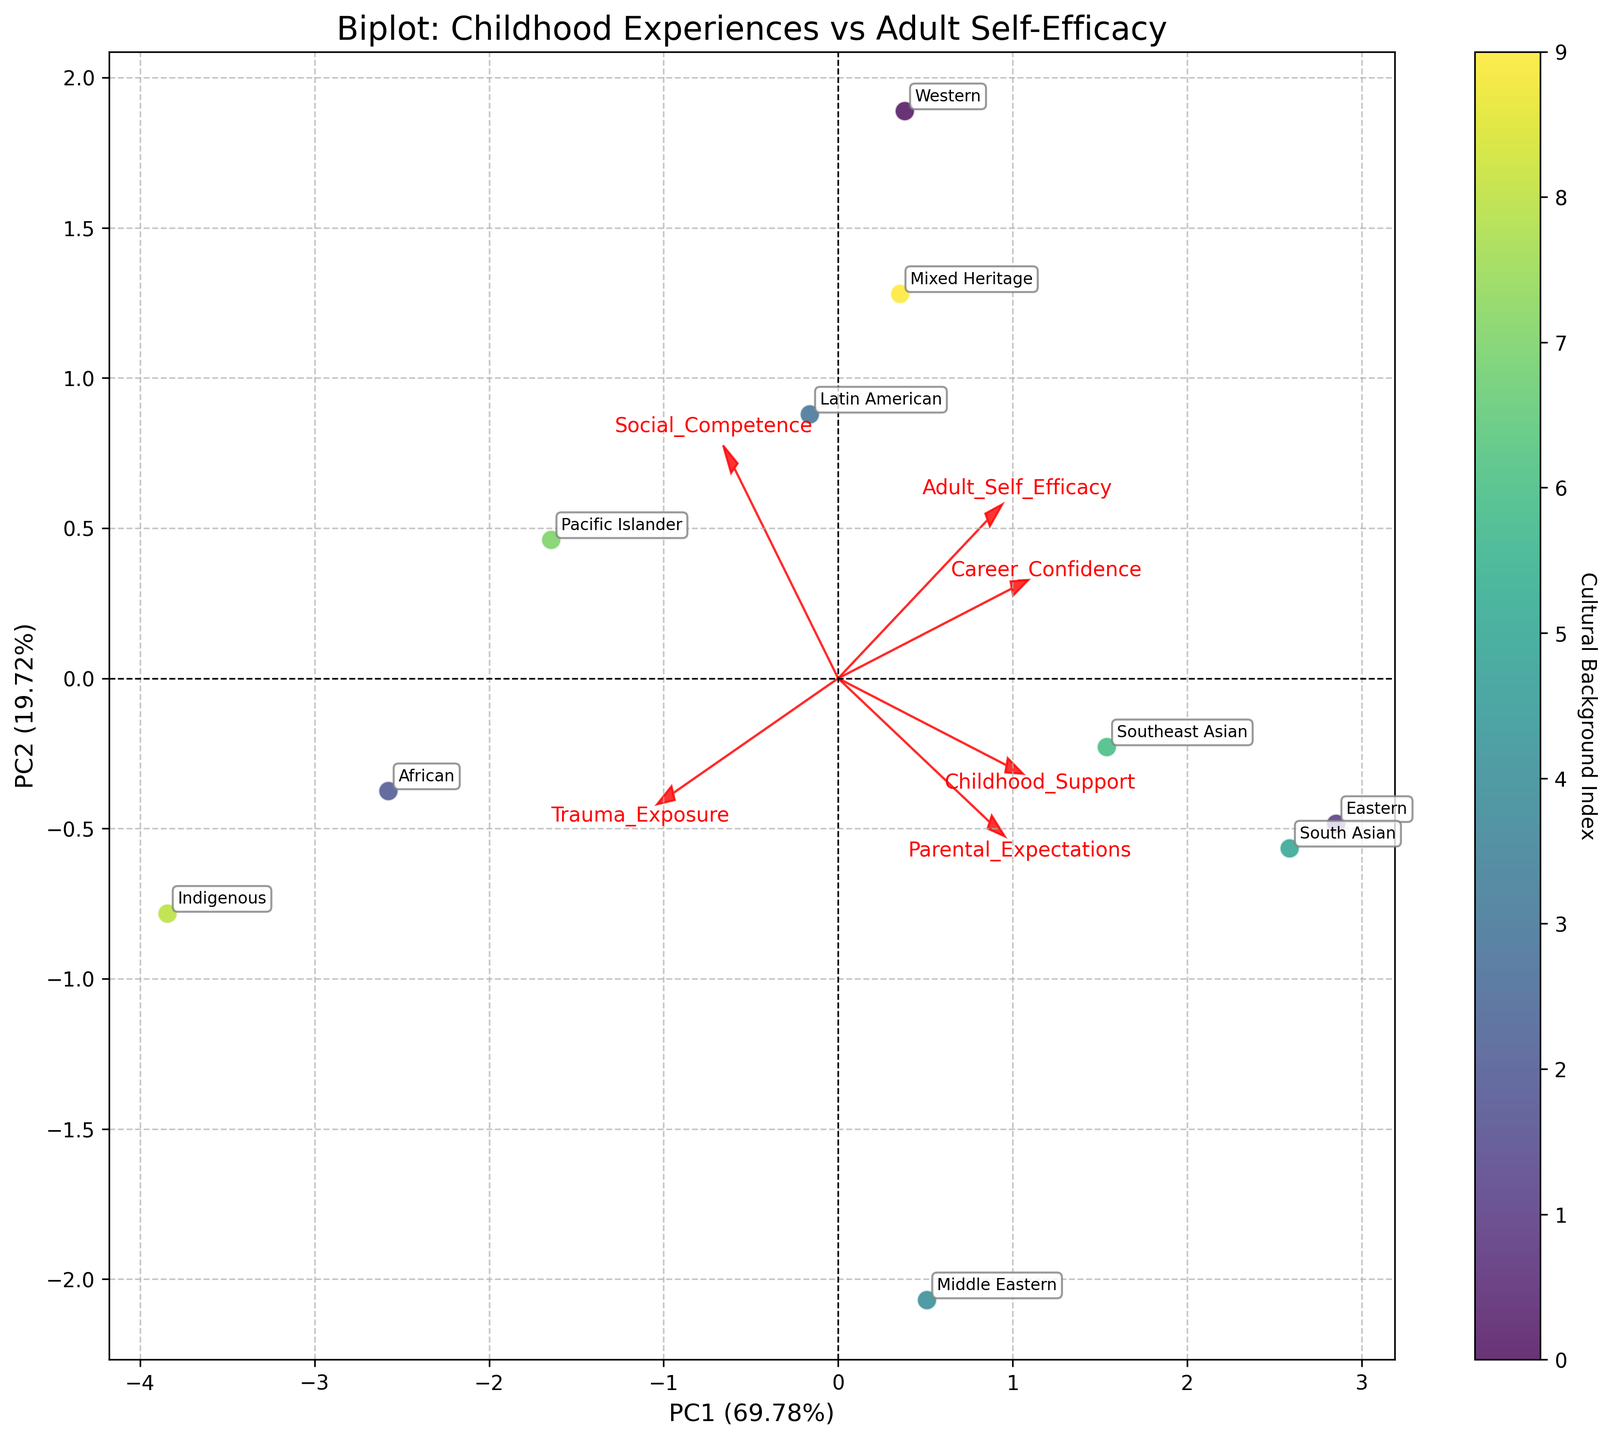What's the title of the biplot? The title can usually be found at the top center part of the plot. Here, it's written to explain what the biplot is about.
Answer: Biplot: Childhood Experiences vs Adult Self-Efficacy How many cultural backgrounds are represented in the biplot? By looking at the labels of the points, each data point is associated with a different cultural background. Counting these labels will give the number of different cultural backgrounds.
Answer: 10 Which variable appears to have the highest loading on PC1 (Principal Component 1)? Loadings are represented by arrows; the length of the arrow indicates the magnitude of the loading. The variable with the longest arrow in the direction of PC1 has the highest loading.
Answer: Childhood Support Which two cultural backgrounds appear most similar based on their coordinates in the biplot? By examining the positioning of the points, we can identify two cultural backgrounds that are close to each other, indicating similar scores on the principal components.
Answer: Western and Pacific Islander Which cultural background has the highest score on PC2 (Principal Component 2)? Look at the vertical position (y-axis) of the points. The cultural background corresponding to the highest y-value has the highest PC2 score.
Answer: Latin American How do 'Parental Expectations' and 'Career Confidence' correlate based on the direction of their loadings? By examining the direction of the arrows for 'Parental Expectations' and 'Career Confidence', we can observe whether they point in the same direction (positive correlation) or opposite directions (negative correlation).
Answer: Positive correlation Which cultural background has the lowest self-efficacy according to PC1? Find the lowest position on the PC1 axis (x-axis) and identify the corresponding cultural background label.
Answer: Indigenous What is the main contribution of 'Trauma Exposure' to the principal components? Examine the direction and length of the arrow for 'Trauma Exposure' to determine its influence on PC1 and PC2.
Answer: Primarily contributes negatively on both PC1 and PC2 Are the cultural backgrounds more spread along PC1 or PC2? Compare the range of the data points along the x-axis (PC1) and y-axis (PC2). The axis with a larger spread indicates more variation along that component.
Answer: PC1 How does 'Social Competence' relate to 'Adult Self-Efficacy' based on their loadings? Look at the directions of the arrows for 'Social Competence' and 'Adult Self-Efficacy' to see if they point in the same direction or not.
Answer: Positive correlation 